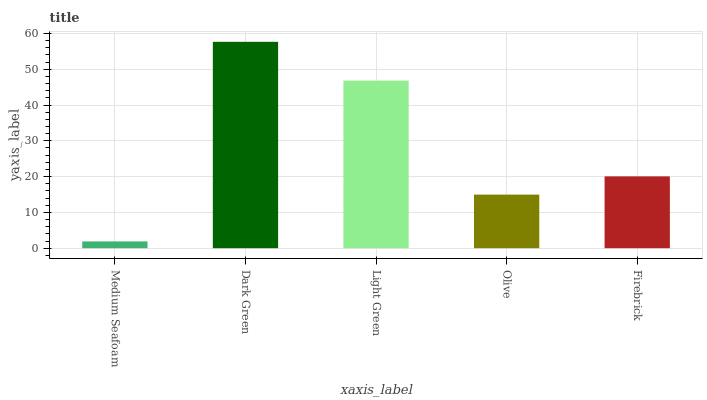Is Light Green the minimum?
Answer yes or no. No. Is Light Green the maximum?
Answer yes or no. No. Is Dark Green greater than Light Green?
Answer yes or no. Yes. Is Light Green less than Dark Green?
Answer yes or no. Yes. Is Light Green greater than Dark Green?
Answer yes or no. No. Is Dark Green less than Light Green?
Answer yes or no. No. Is Firebrick the high median?
Answer yes or no. Yes. Is Firebrick the low median?
Answer yes or no. Yes. Is Olive the high median?
Answer yes or no. No. Is Olive the low median?
Answer yes or no. No. 